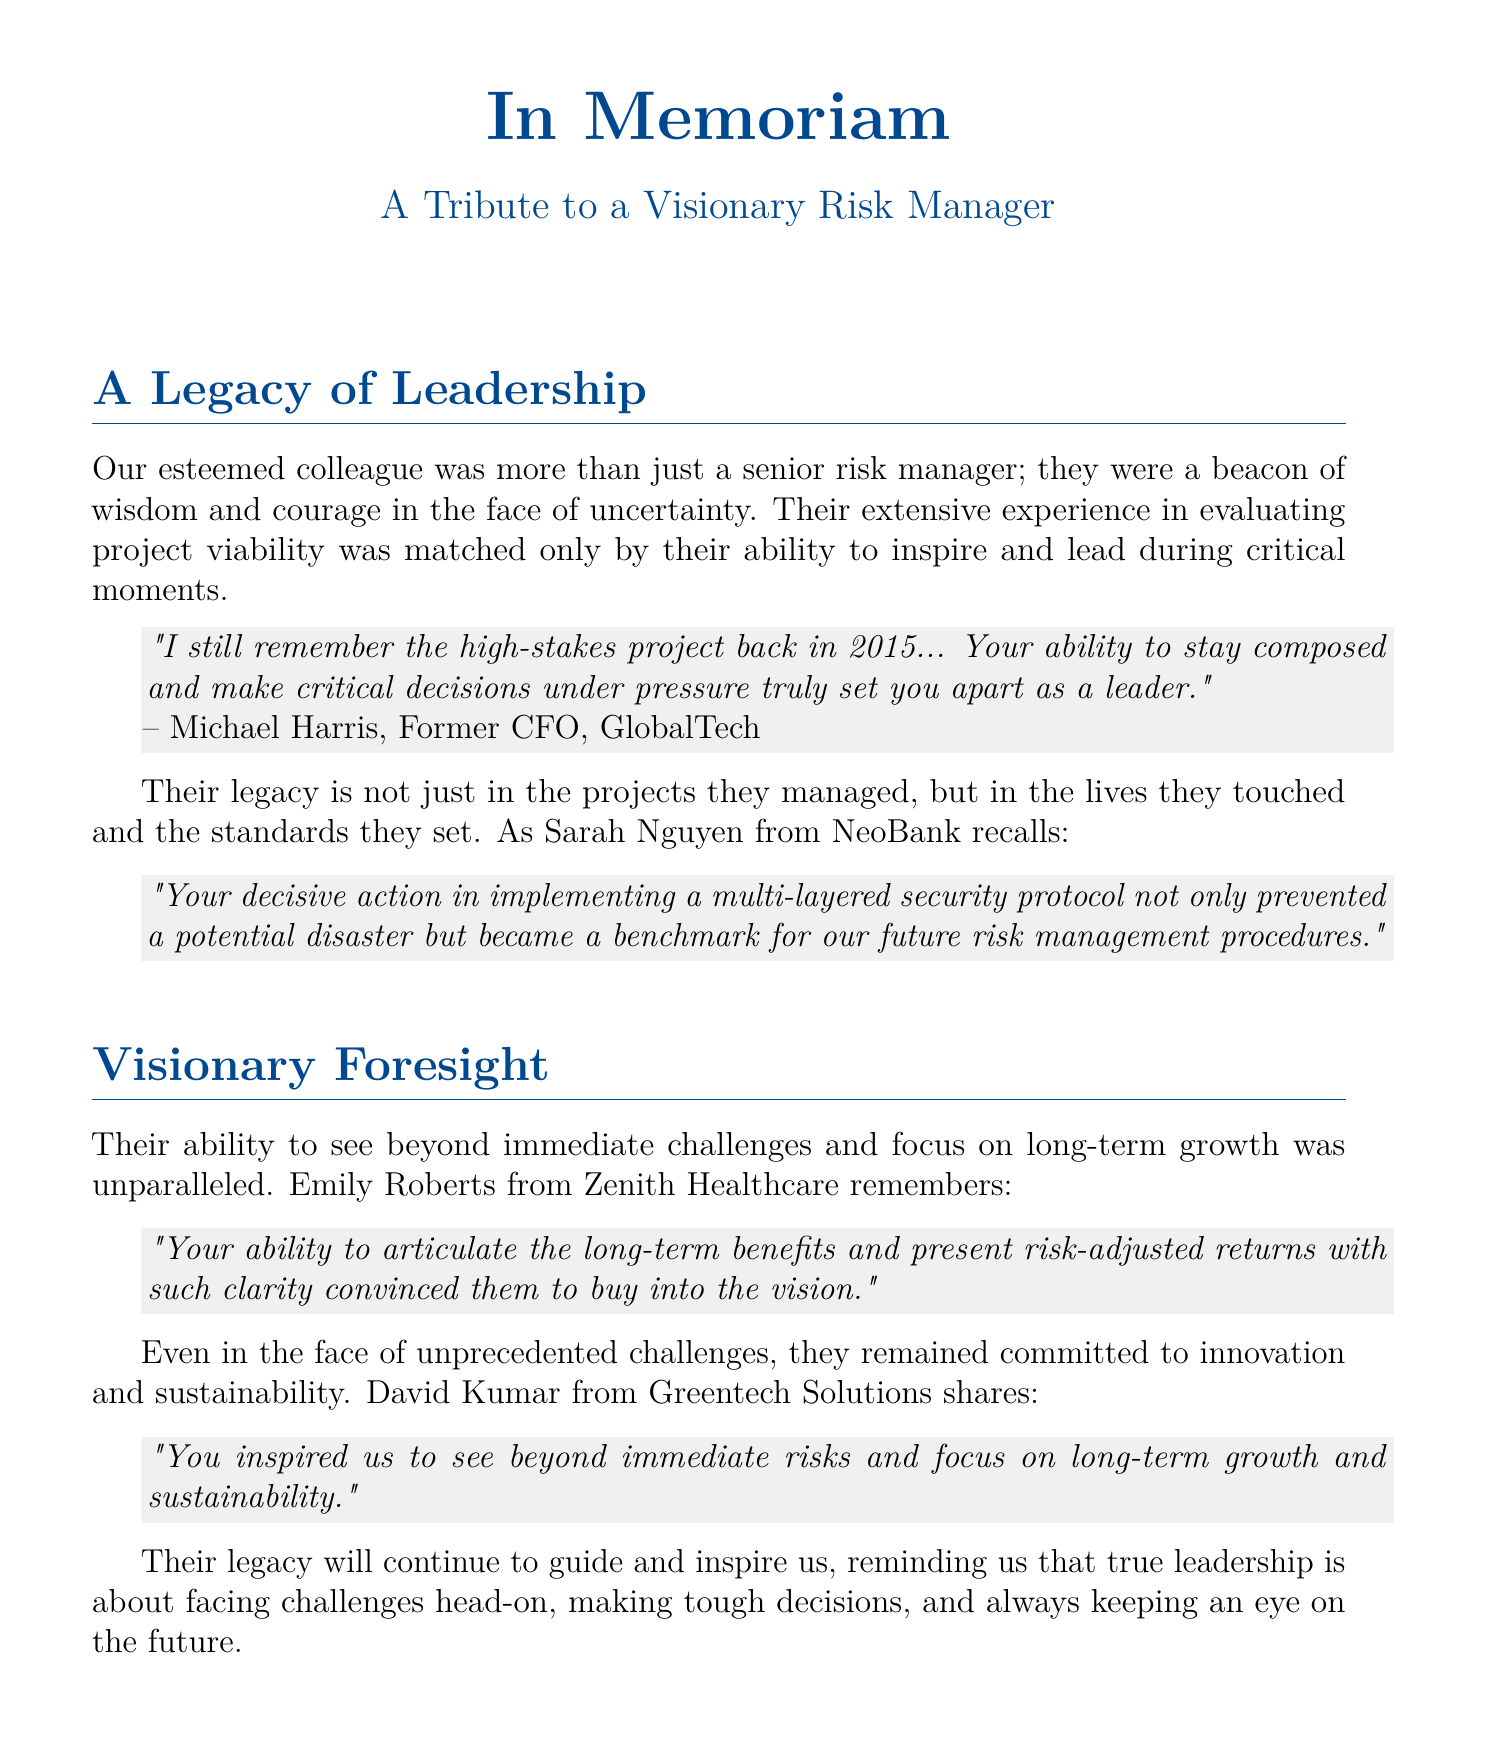What is the document about? The document serves as a eulogy, honoring a senior risk manager and reflecting on their leadership and contributions.
Answer: A Tribute to a Visionary Risk Manager Who is cited as recalling a high-stakes project from 2015? Michael Harris, who was formerly a CFO at GlobalTech, shares a personal anecdote about the honoree’s leadership during a project.
Answer: Michael Harris What did Sarah Nguyen from NeoBank say about the honoree's actions? She noted the implementation of a multi-layered security protocol and its impact on risk management procedures.
Answer: Prevented a potential disaster What quality of the honoree is highlighted in Emily Roberts' testimonial? Emily emphasizes the honoree's ability to articulate long-term benefits and present risk-adjusted returns.
Answer: Visionary Foresight Which company does David Kumar associate with in his testimonial? He shares his reflections on the honoree's focus on long-term growth from his perspective at Greentech Solutions.
Answer: Greentech Solutions What significant value does the document convey regarding leadership? It underscores the importance of facing challenges, making tough decisions, and focusing on the future.
Answer: True leadership How many colleagues provided testimonials in the document? There are four distinct testimonials shared from different colleagues regarding the honoree's character and leadership.
Answer: Four What is the tone of testimonies shared in this eulogy? The testimonies express admiration and respect for the honoree's leadership during critical decision-making moments.
Answer: Respectful What year is explicitly mentioned in Michael Harris's reflection? The year provided in the context of the high-stakes project is 2015.
Answer: 2015 